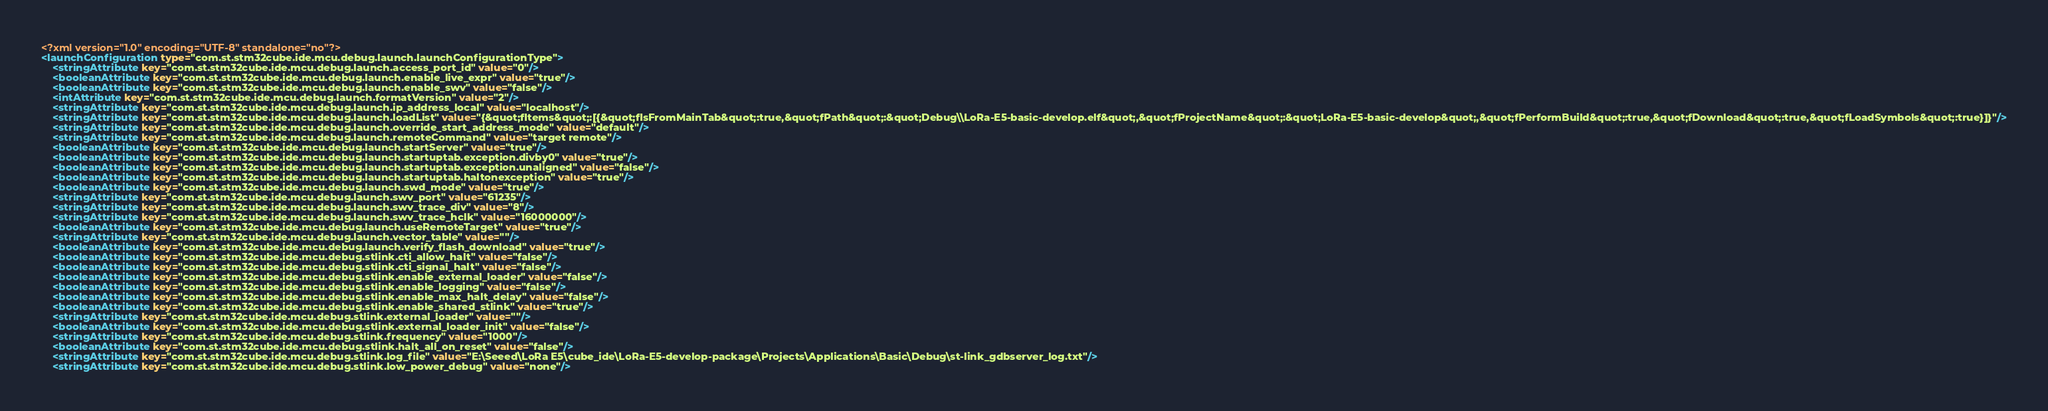<code> <loc_0><loc_0><loc_500><loc_500><_XML_><?xml version="1.0" encoding="UTF-8" standalone="no"?>
<launchConfiguration type="com.st.stm32cube.ide.mcu.debug.launch.launchConfigurationType">
    <stringAttribute key="com.st.stm32cube.ide.mcu.debug.launch.access_port_id" value="0"/>
    <booleanAttribute key="com.st.stm32cube.ide.mcu.debug.launch.enable_live_expr" value="true"/>
    <booleanAttribute key="com.st.stm32cube.ide.mcu.debug.launch.enable_swv" value="false"/>
    <intAttribute key="com.st.stm32cube.ide.mcu.debug.launch.formatVersion" value="2"/>
    <stringAttribute key="com.st.stm32cube.ide.mcu.debug.launch.ip_address_local" value="localhost"/>
    <stringAttribute key="com.st.stm32cube.ide.mcu.debug.launch.loadList" value="{&quot;fItems&quot;:[{&quot;fIsFromMainTab&quot;:true,&quot;fPath&quot;:&quot;Debug\\LoRa-E5-basic-develop.elf&quot;,&quot;fProjectName&quot;:&quot;LoRa-E5-basic-develop&quot;,&quot;fPerformBuild&quot;:true,&quot;fDownload&quot;:true,&quot;fLoadSymbols&quot;:true}]}"/>
    <stringAttribute key="com.st.stm32cube.ide.mcu.debug.launch.override_start_address_mode" value="default"/>
    <stringAttribute key="com.st.stm32cube.ide.mcu.debug.launch.remoteCommand" value="target remote"/>
    <booleanAttribute key="com.st.stm32cube.ide.mcu.debug.launch.startServer" value="true"/>
    <booleanAttribute key="com.st.stm32cube.ide.mcu.debug.launch.startuptab.exception.divby0" value="true"/>
    <booleanAttribute key="com.st.stm32cube.ide.mcu.debug.launch.startuptab.exception.unaligned" value="false"/>
    <booleanAttribute key="com.st.stm32cube.ide.mcu.debug.launch.startuptab.haltonexception" value="true"/>
    <booleanAttribute key="com.st.stm32cube.ide.mcu.debug.launch.swd_mode" value="true"/>
    <stringAttribute key="com.st.stm32cube.ide.mcu.debug.launch.swv_port" value="61235"/>
    <stringAttribute key="com.st.stm32cube.ide.mcu.debug.launch.swv_trace_div" value="8"/>
    <stringAttribute key="com.st.stm32cube.ide.mcu.debug.launch.swv_trace_hclk" value="16000000"/>
    <booleanAttribute key="com.st.stm32cube.ide.mcu.debug.launch.useRemoteTarget" value="true"/>
    <stringAttribute key="com.st.stm32cube.ide.mcu.debug.launch.vector_table" value=""/>
    <booleanAttribute key="com.st.stm32cube.ide.mcu.debug.launch.verify_flash_download" value="true"/>
    <booleanAttribute key="com.st.stm32cube.ide.mcu.debug.stlink.cti_allow_halt" value="false"/>
    <booleanAttribute key="com.st.stm32cube.ide.mcu.debug.stlink.cti_signal_halt" value="false"/>
    <booleanAttribute key="com.st.stm32cube.ide.mcu.debug.stlink.enable_external_loader" value="false"/>
    <booleanAttribute key="com.st.stm32cube.ide.mcu.debug.stlink.enable_logging" value="false"/>
    <booleanAttribute key="com.st.stm32cube.ide.mcu.debug.stlink.enable_max_halt_delay" value="false"/>
    <booleanAttribute key="com.st.stm32cube.ide.mcu.debug.stlink.enable_shared_stlink" value="true"/>
    <stringAttribute key="com.st.stm32cube.ide.mcu.debug.stlink.external_loader" value=""/>
    <booleanAttribute key="com.st.stm32cube.ide.mcu.debug.stlink.external_loader_init" value="false"/>
    <stringAttribute key="com.st.stm32cube.ide.mcu.debug.stlink.frequency" value="1000"/>
    <booleanAttribute key="com.st.stm32cube.ide.mcu.debug.stlink.halt_all_on_reset" value="false"/>
    <stringAttribute key="com.st.stm32cube.ide.mcu.debug.stlink.log_file" value="E:\Seeed\LoRa E5\cube_ide\LoRa-E5-develop-package\Projects\Applications\Basic\Debug\st-link_gdbserver_log.txt"/>
    <stringAttribute key="com.st.stm32cube.ide.mcu.debug.stlink.low_power_debug" value="none"/></code> 